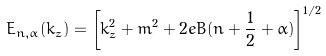<formula> <loc_0><loc_0><loc_500><loc_500>E _ { n , \alpha } ( k _ { z } ) = \left [ k _ { z } ^ { 2 } + m ^ { 2 } + 2 e B ( n + \frac { 1 } { 2 } + \alpha ) \right ] ^ { 1 / 2 }</formula> 